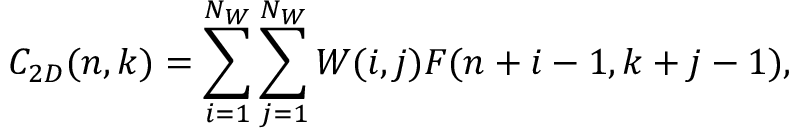Convert formula to latex. <formula><loc_0><loc_0><loc_500><loc_500>C _ { 2 D } ( n , k ) = \sum _ { i = 1 } ^ { N _ { W } } \sum _ { j = 1 } ^ { N _ { W } } W ( i , j ) F ( n + i - 1 , k + j - 1 ) ,</formula> 